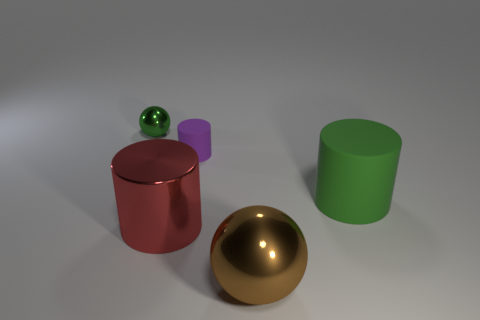Add 3 metallic things. How many objects exist? 8 Subtract 1 cylinders. How many cylinders are left? 2 Subtract all brown spheres. How many spheres are left? 1 Subtract all rubber cylinders. How many cylinders are left? 1 Subtract 0 green blocks. How many objects are left? 5 Subtract all cylinders. How many objects are left? 2 Subtract all green balls. Subtract all gray cylinders. How many balls are left? 1 Subtract all gray cubes. How many red cylinders are left? 1 Subtract all gray matte spheres. Subtract all big green objects. How many objects are left? 4 Add 4 purple matte cylinders. How many purple matte cylinders are left? 5 